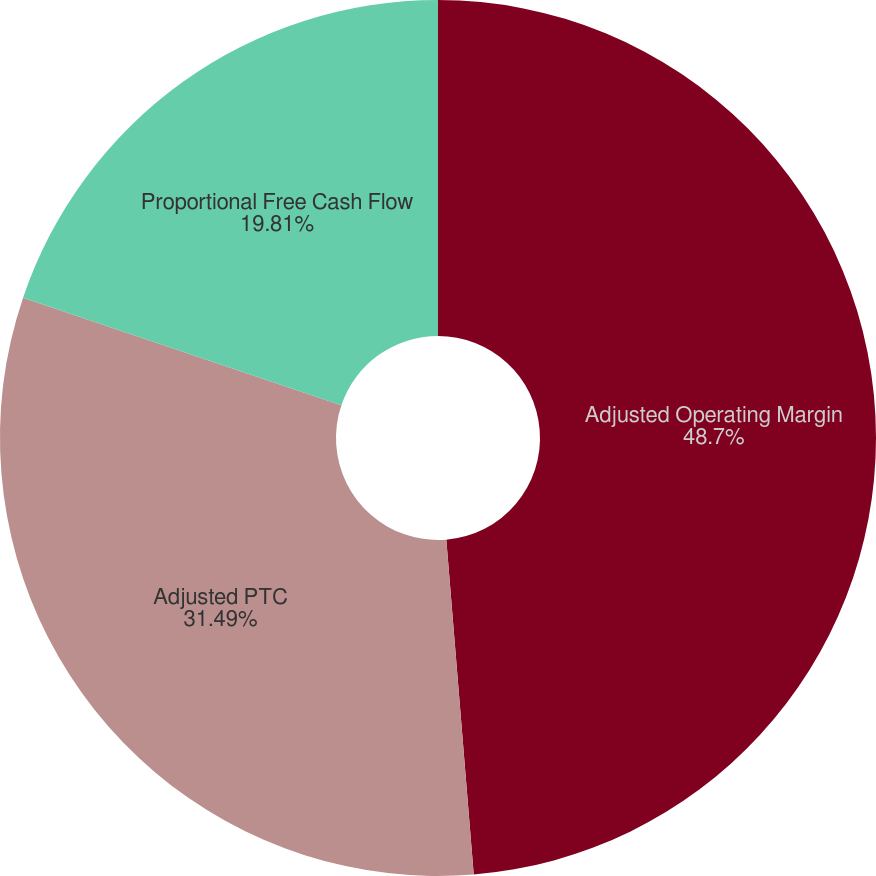Convert chart to OTSL. <chart><loc_0><loc_0><loc_500><loc_500><pie_chart><fcel>Adjusted Operating Margin<fcel>Adjusted PTC<fcel>Proportional Free Cash Flow<nl><fcel>48.7%<fcel>31.49%<fcel>19.81%<nl></chart> 